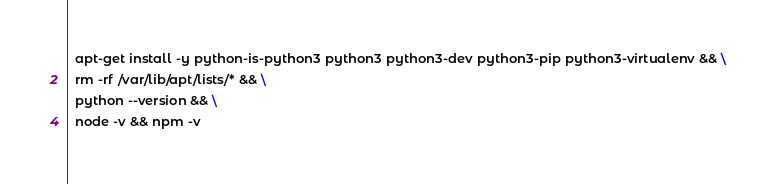<code> <loc_0><loc_0><loc_500><loc_500><_Dockerfile_>  apt-get install -y python-is-python3 python3 python3-dev python3-pip python3-virtualenv && \
  rm -rf /var/lib/apt/lists/* && \
  python --version && \
  node -v && npm -v</code> 